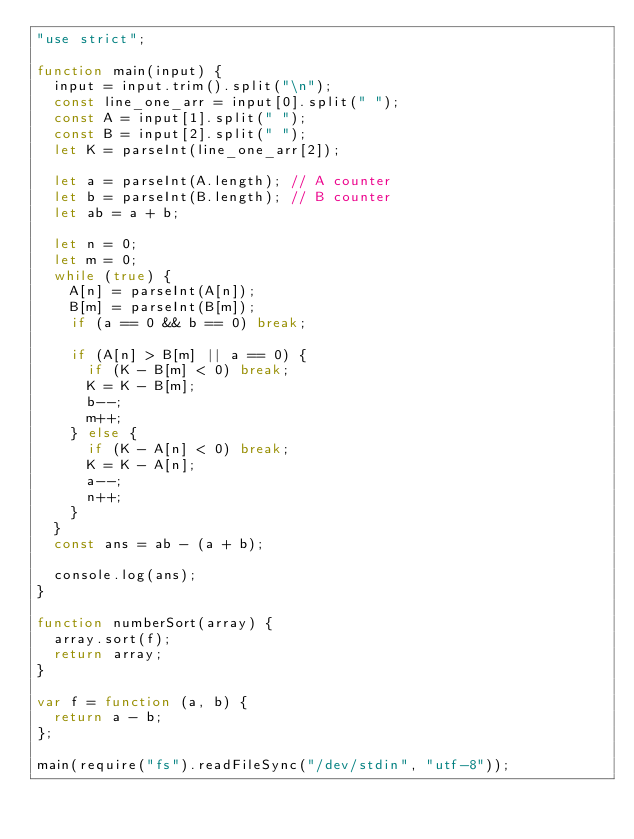<code> <loc_0><loc_0><loc_500><loc_500><_JavaScript_>"use strict";

function main(input) {
  input = input.trim().split("\n");
  const line_one_arr = input[0].split(" ");
  const A = input[1].split(" ");
  const B = input[2].split(" ");
  let K = parseInt(line_one_arr[2]);

  let a = parseInt(A.length); // A counter
  let b = parseInt(B.length); // B counter
  let ab = a + b;

  let n = 0;
  let m = 0;
  while (true) {
    A[n] = parseInt(A[n]);
    B[m] = parseInt(B[m]);
    if (a == 0 && b == 0) break;

    if (A[n] > B[m] || a == 0) {
      if (K - B[m] < 0) break;
      K = K - B[m];
      b--;
      m++;
    } else {
      if (K - A[n] < 0) break;
      K = K - A[n];
      a--;
      n++;
    }
  }
  const ans = ab - (a + b);

  console.log(ans);
}

function numberSort(array) {
  array.sort(f);
  return array;
}

var f = function (a, b) {
  return a - b;
};

main(require("fs").readFileSync("/dev/stdin", "utf-8"));
</code> 